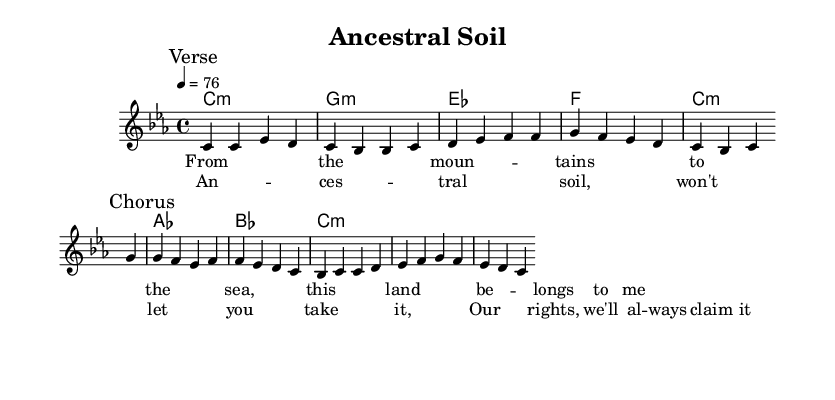What is the key signature of this music? The key signature is indicated as C minor, showing that there are three flats (B♭, E♭, and A♭) in the key signature.
Answer: C minor What is the time signature of this piece? The time signature is noted as 4/4, which means there are four beats in each measure and the quarter note gets one beat.
Answer: 4/4 What is the tempo marking in beats per minute? The tempo is marked as 76, which refers to 76 beats per minute, indicating the speed of the music.
Answer: 76 How many measures are in the verse section? The verse section contains four measures, as indicated by the group of notes before the first break notation.
Answer: 4 What are the main themes of the lyrics in this piece? The lyrics focus on themes of land ownership and ancestral rights, emphasizing a deep connection to the land.
Answer: Land ownership and ancestral rights What chord follows the melody in the first part of the verse? The first melody line is accompanied by a C minor chord, as indicated by the chord notation directly below the melody notes.
Answer: C minor What do the lyrics in the chorus emphasize regarding land rights? The lyrics express a strong determination to maintain land rights, highlighting that it belongs to them and affirming their claims.
Answer: Claiming land rights 